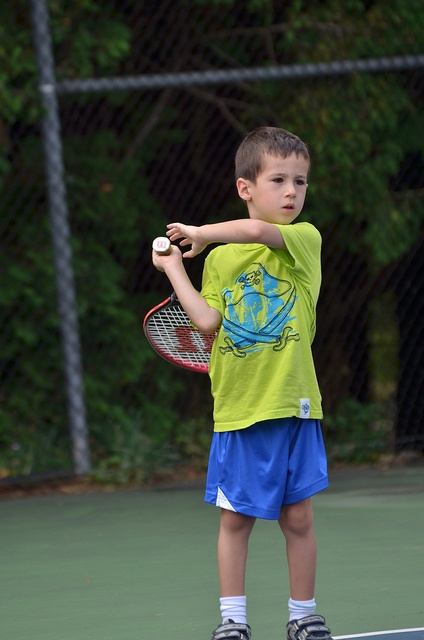Describe the objects in this image and their specific colors. I can see people in black, olive, gray, and khaki tones and tennis racket in black, darkgray, gray, and maroon tones in this image. 